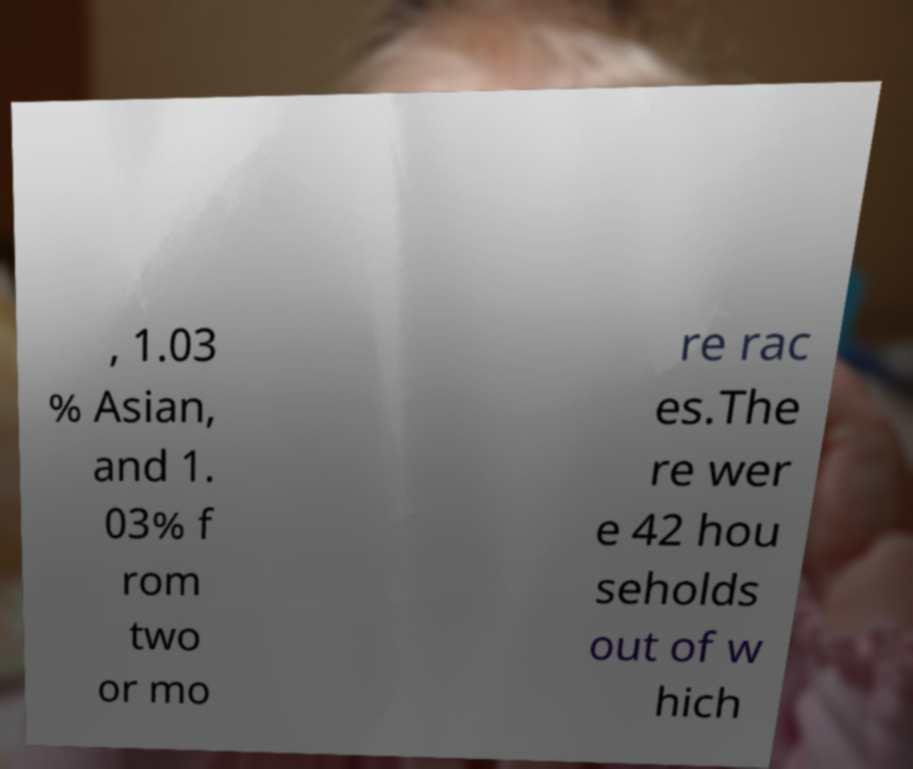What messages or text are displayed in this image? I need them in a readable, typed format. , 1.03 % Asian, and 1. 03% f rom two or mo re rac es.The re wer e 42 hou seholds out of w hich 